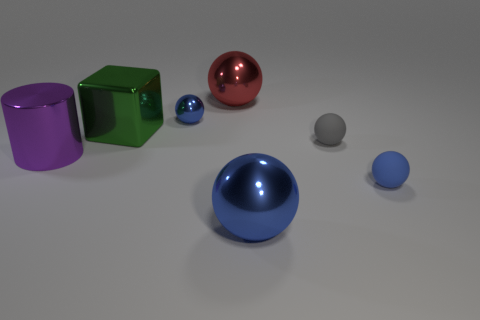Subtract all green cylinders. Subtract all yellow balls. How many cylinders are left? 1 Subtract all yellow blocks. How many red cylinders are left? 0 Add 7 blues. How many small grays exist? 0 Subtract all big green metallic things. Subtract all large spheres. How many objects are left? 4 Add 7 green blocks. How many green blocks are left? 8 Add 7 big brown rubber cubes. How many big brown rubber cubes exist? 7 Add 1 large red metal things. How many objects exist? 8 Subtract all gray balls. How many balls are left? 4 Subtract all big spheres. How many spheres are left? 3 Subtract 1 gray balls. How many objects are left? 6 